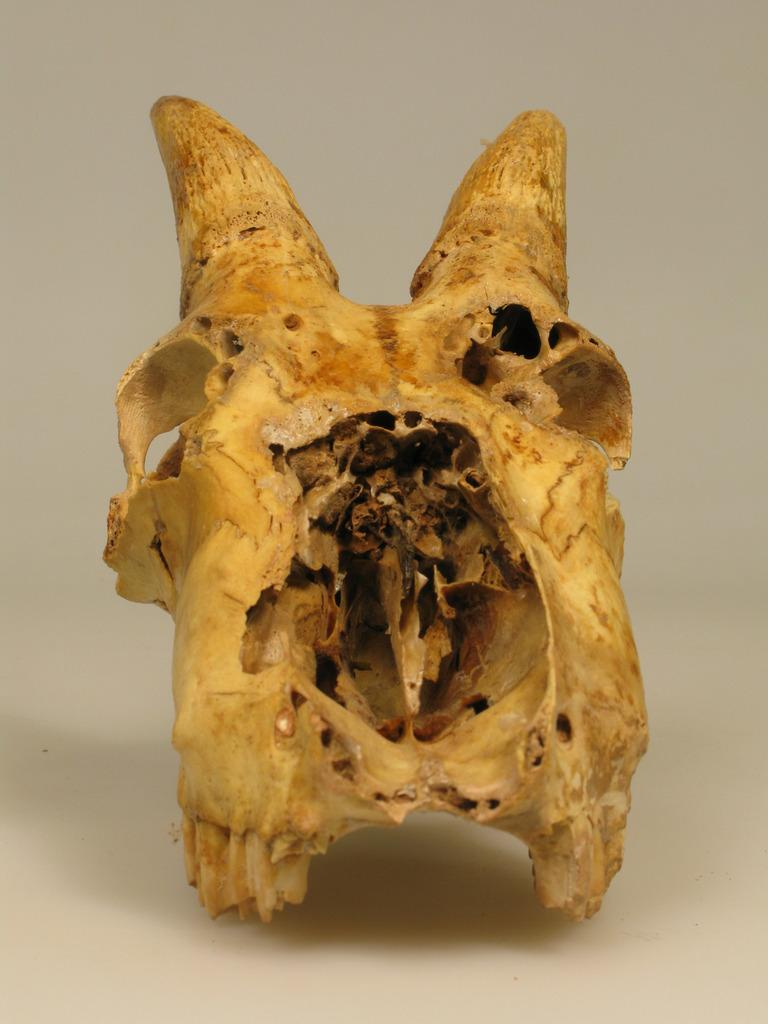What is the main subject of the image? The main subject of the image is an object that looks like a skull. What type of key is used to unlock the record in the image? There is no key or record present in the image; it only features an object that looks like a skull. 